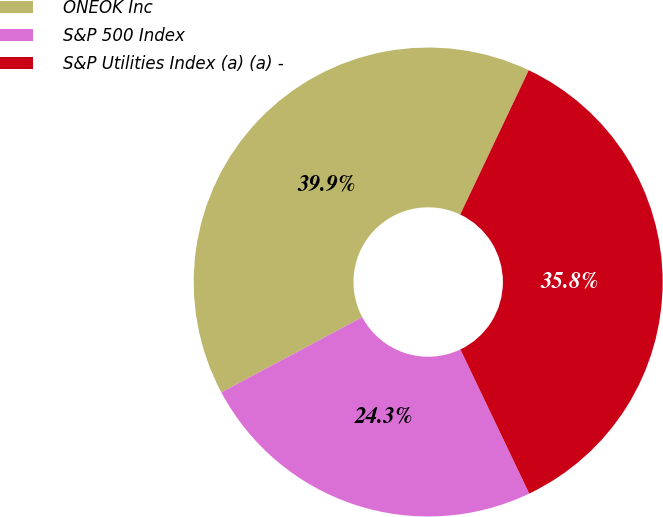<chart> <loc_0><loc_0><loc_500><loc_500><pie_chart><fcel>ONEOK Inc<fcel>S&P 500 Index<fcel>S&P Utilities Index (a) (a) -<nl><fcel>39.86%<fcel>24.29%<fcel>35.85%<nl></chart> 